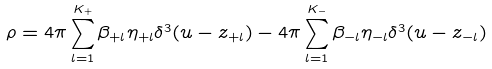<formula> <loc_0><loc_0><loc_500><loc_500>\rho = 4 \pi \sum _ { l = 1 } ^ { K _ { + } } \beta _ { + l } \eta _ { + l } \delta ^ { 3 } ( u - z _ { + l } ) - 4 \pi \sum _ { l = 1 } ^ { K _ { - } } \beta _ { - l } \eta _ { - l } \delta ^ { 3 } ( u - z _ { - l } )</formula> 